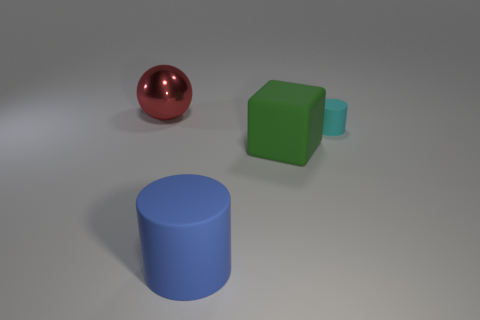Add 2 tiny purple metal things. How many objects exist? 6 Subtract all cubes. How many objects are left? 3 Add 3 big cyan blocks. How many big cyan blocks exist? 3 Subtract 1 cyan cylinders. How many objects are left? 3 Subtract all big blue things. Subtract all cyan spheres. How many objects are left? 3 Add 1 large red objects. How many large red objects are left? 2 